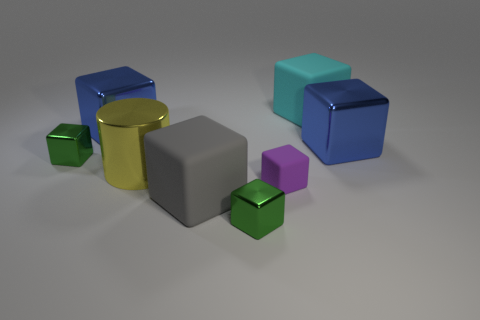Subtract 4 blocks. How many blocks are left? 3 Subtract all gray cubes. How many cubes are left? 6 Subtract all small purple matte cubes. How many cubes are left? 6 Subtract all blue blocks. Subtract all green spheres. How many blocks are left? 5 Add 1 tiny green shiny cubes. How many objects exist? 9 Subtract all cylinders. How many objects are left? 7 Add 6 cyan matte cubes. How many cyan matte cubes are left? 7 Add 3 red things. How many red things exist? 3 Subtract 0 cyan spheres. How many objects are left? 8 Subtract all gray cubes. Subtract all large brown cylinders. How many objects are left? 7 